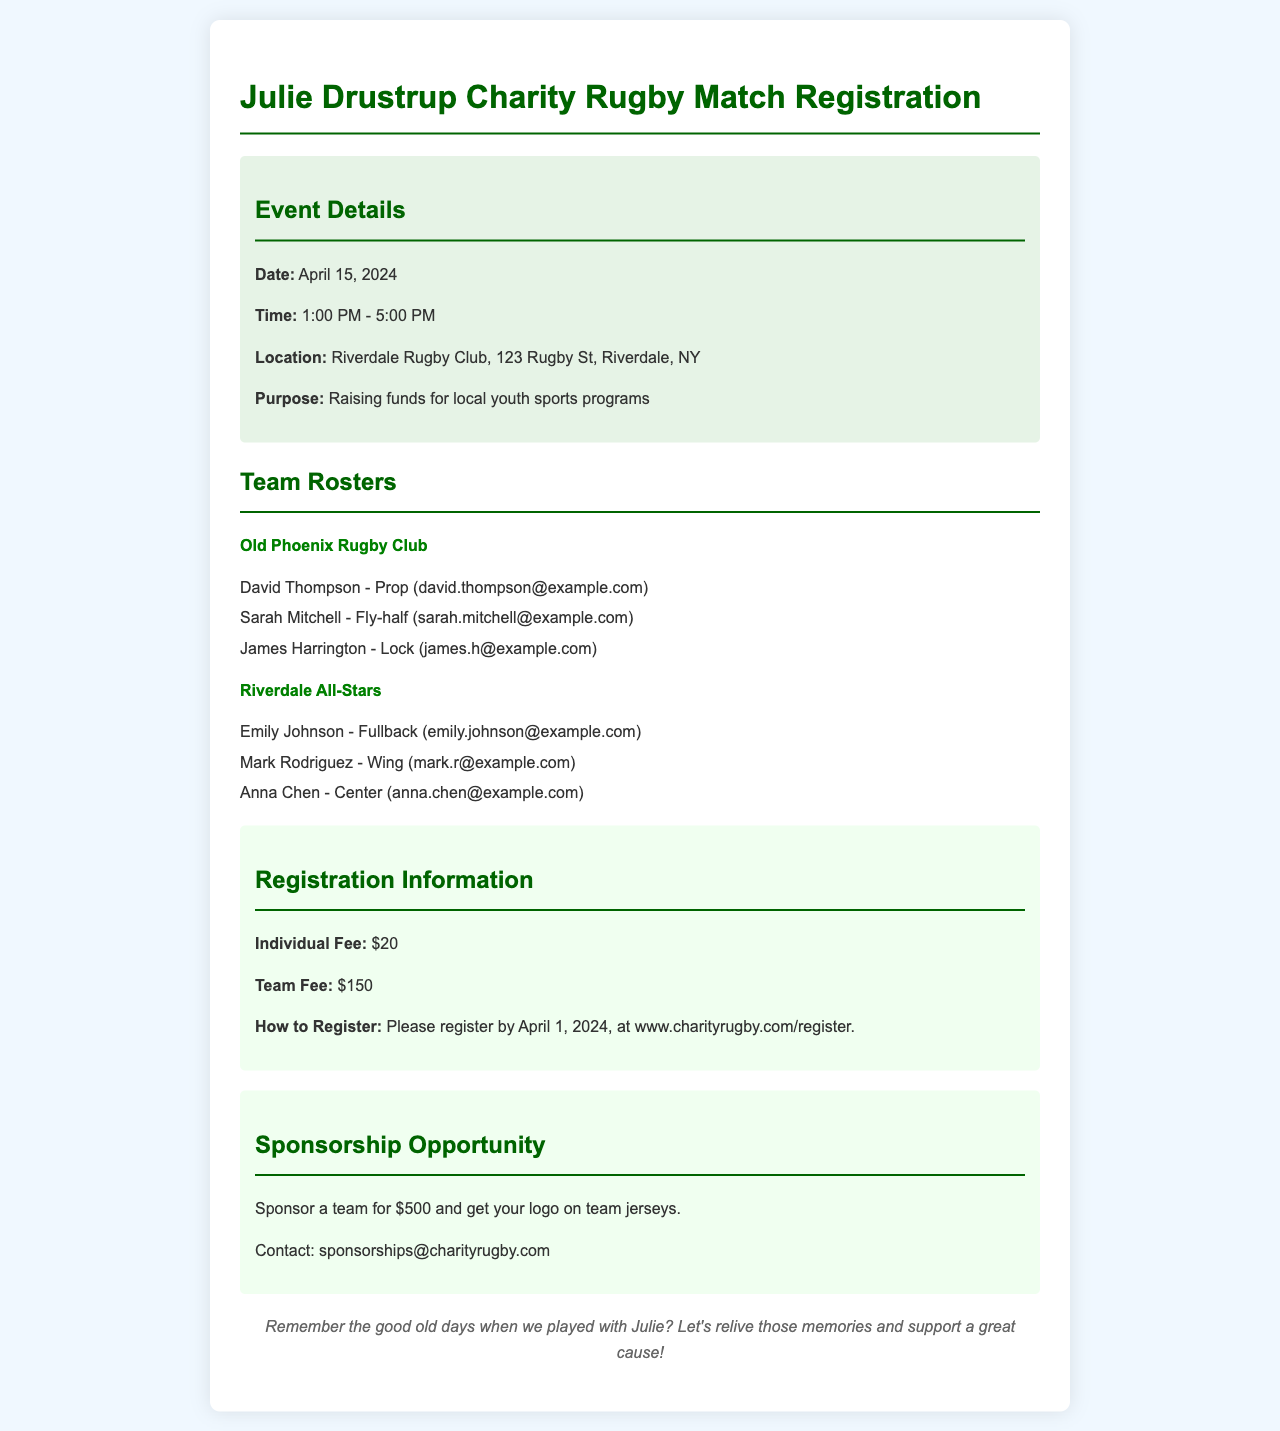What is the date of the charity rugby match? The date of the match is mentioned in the event details section of the document.
Answer: April 15, 2024 What is the individual registration fee? The individual fee is stated in the registration information section.
Answer: $20 Who is the fly-half for Old Phoenix Rugby Club? The player list for Old Phoenix Rugby Club includes the position of each player.
Answer: Sarah Mitchell What is the purpose of the charity event? The purpose is outlined in the event details section.
Answer: Raising funds for local youth sports programs How many players are listed for the Riverdale All-Stars? The number of players can be counted from the team roster of Riverdale All-Stars.
Answer: 3 What is the team fee for registration? The team fee is provided in the registration information.
Answer: $150 What sponsorship opportunity is available? The sponsorship opportunity along with its details is mentioned in the document.
Answer: Sponsor a team for $500 What is the contact email for sponsorship inquiries? The email for sponsorship inquiries is given at the end of the sponsorship section.
Answer: sponsorships@charityrugby.com What time does the event start? The start time is mentioned in the event details section of the document.
Answer: 1:00 PM 